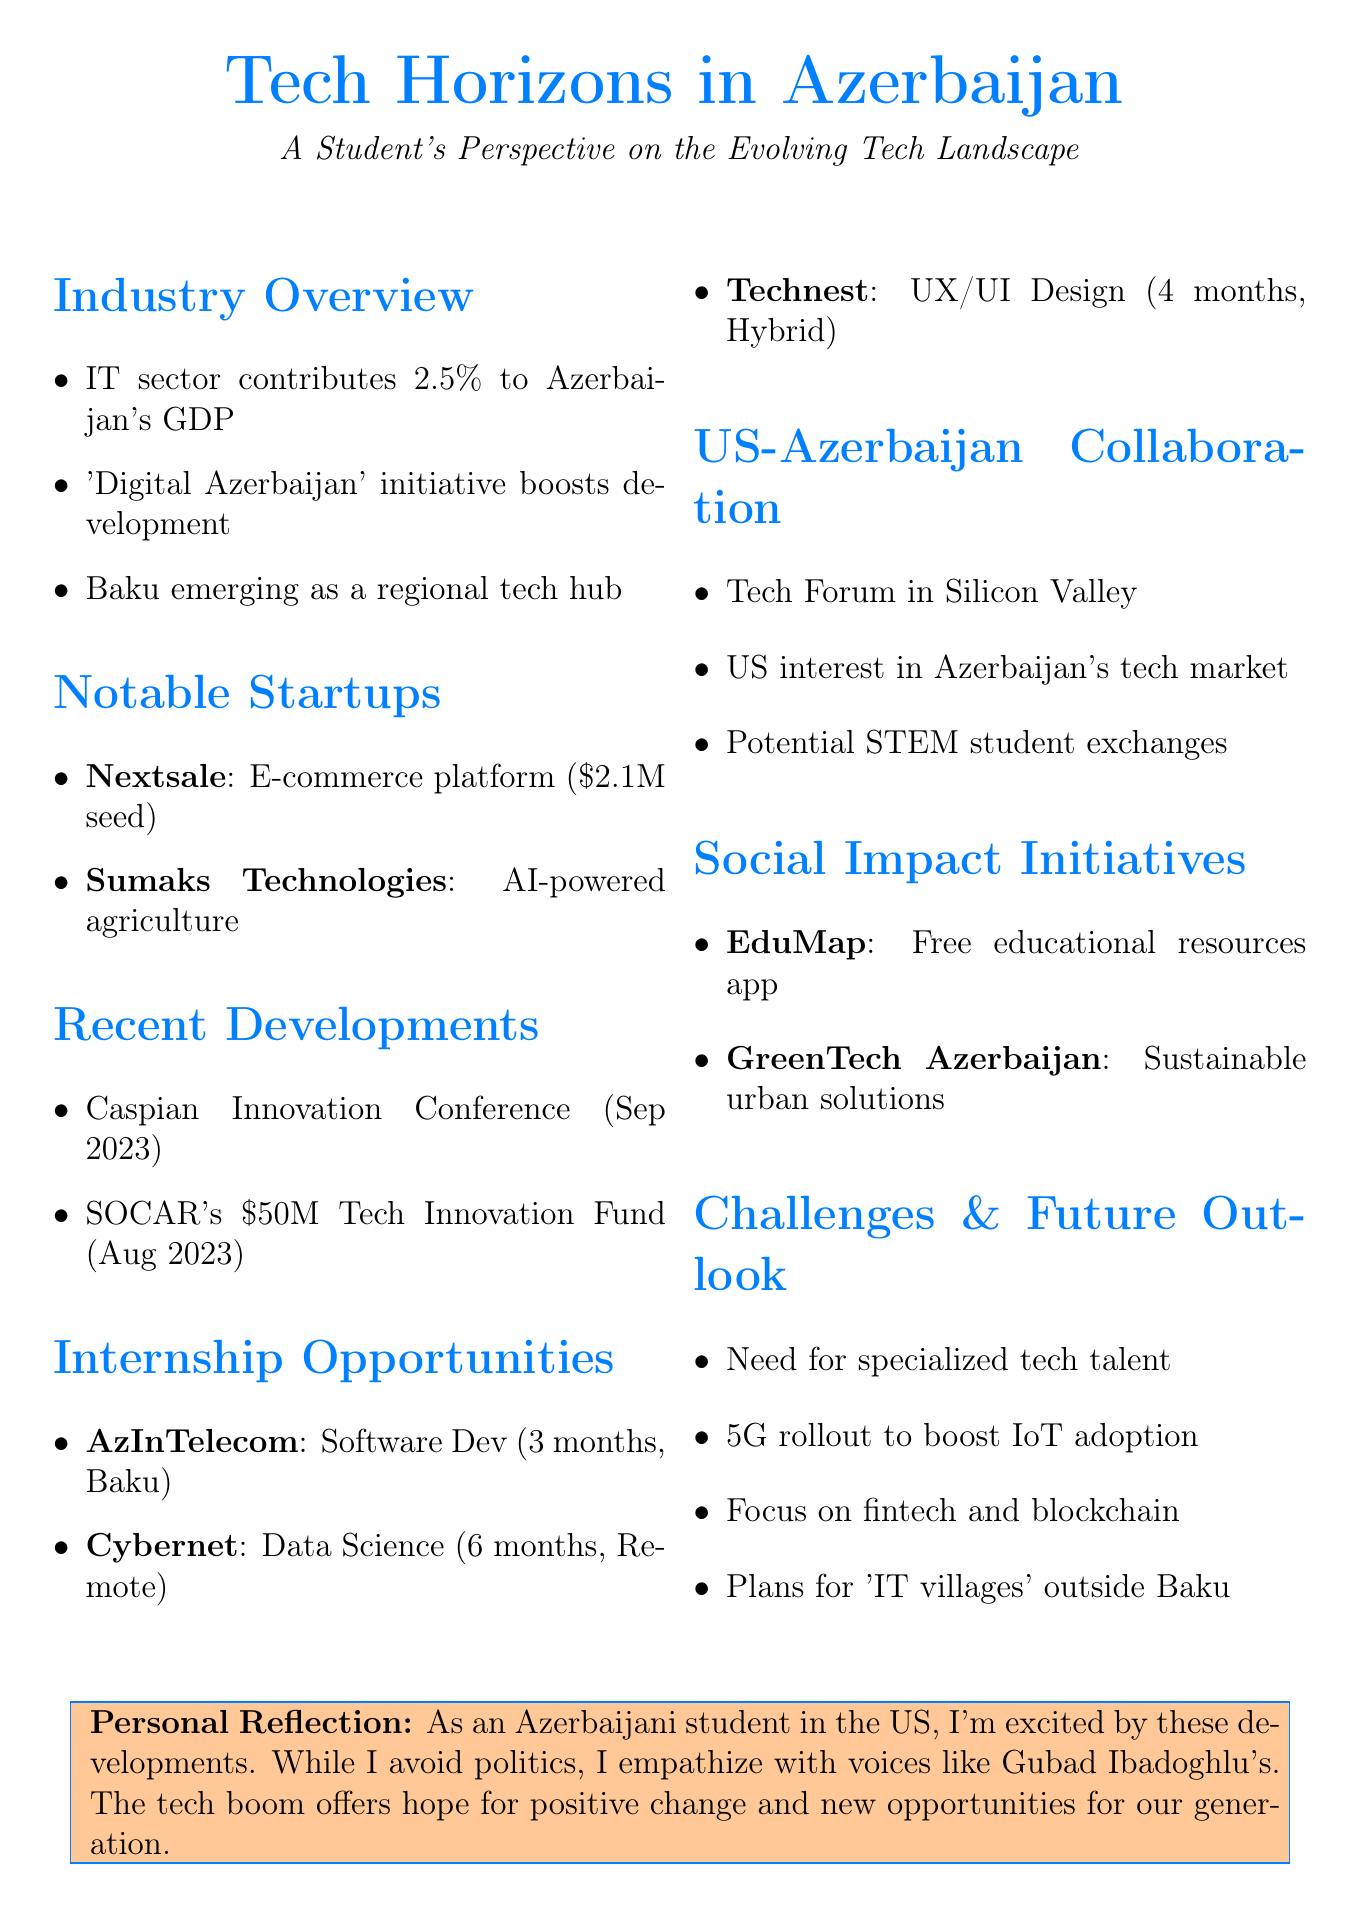What percentage does the IT sector contribute to Azerbaijan's GDP? The document states that the IT sector contributes 2.5% to Azerbaijan's GDP.
Answer: 2.5% What is the funding amount for Nextsale? The document mentions that Nextsale received a $2.1 million seed round in 2022.
Answer: $2.1 million When was the Caspian Innovation Conference held? The document indicates that the conference took place in September 2023.
Answer: September 2023 What internship position is offered by AzInTelecom? The document lists the internship position offered by AzInTelecom as Software Development Intern.
Answer: Software Development Intern Which startup won Startup of the Year at Azerbaijan Innovation Week 2023? The document states that Sumaks Technologies won Startup of the Year at Azerbaijan Innovation Week 2023.
Answer: Sumaks Technologies What are the two main challenges mentioned in the document? The document highlights the need for more specialized tech talent and improving internet infrastructure in rural regions as challenges.
Answer: Specialized tech talent, internet infrastructure What type of forum was held in Silicon Valley? The document describes the event as a Technology Forum.
Answer: Technology Forum Which two social initiatives are mentioned in the document? The document lists EduMap and GreenTech Azerbaijan as social initiatives addressing issues in Azerbaijan.
Answer: EduMap, GreenTech Azerbaijan How long is the Data Science internship with Cybernet? The document states that the Data Science internship with Cybernet lasts for 6 months.
Answer: 6 months 